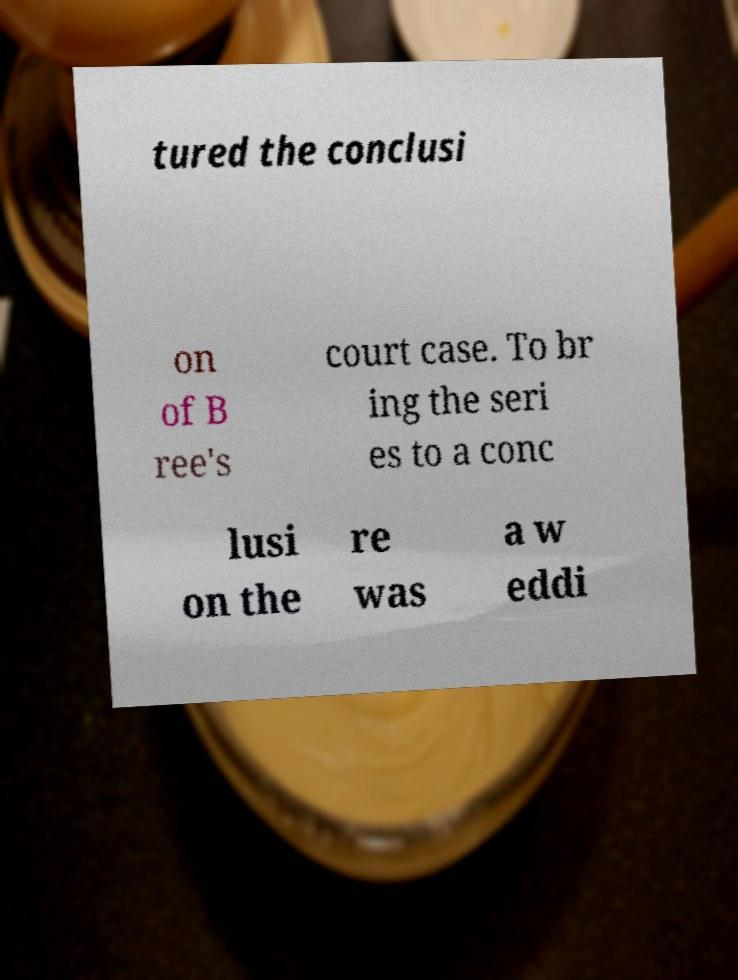Please identify and transcribe the text found in this image. tured the conclusi on of B ree's court case. To br ing the seri es to a conc lusi on the re was a w eddi 